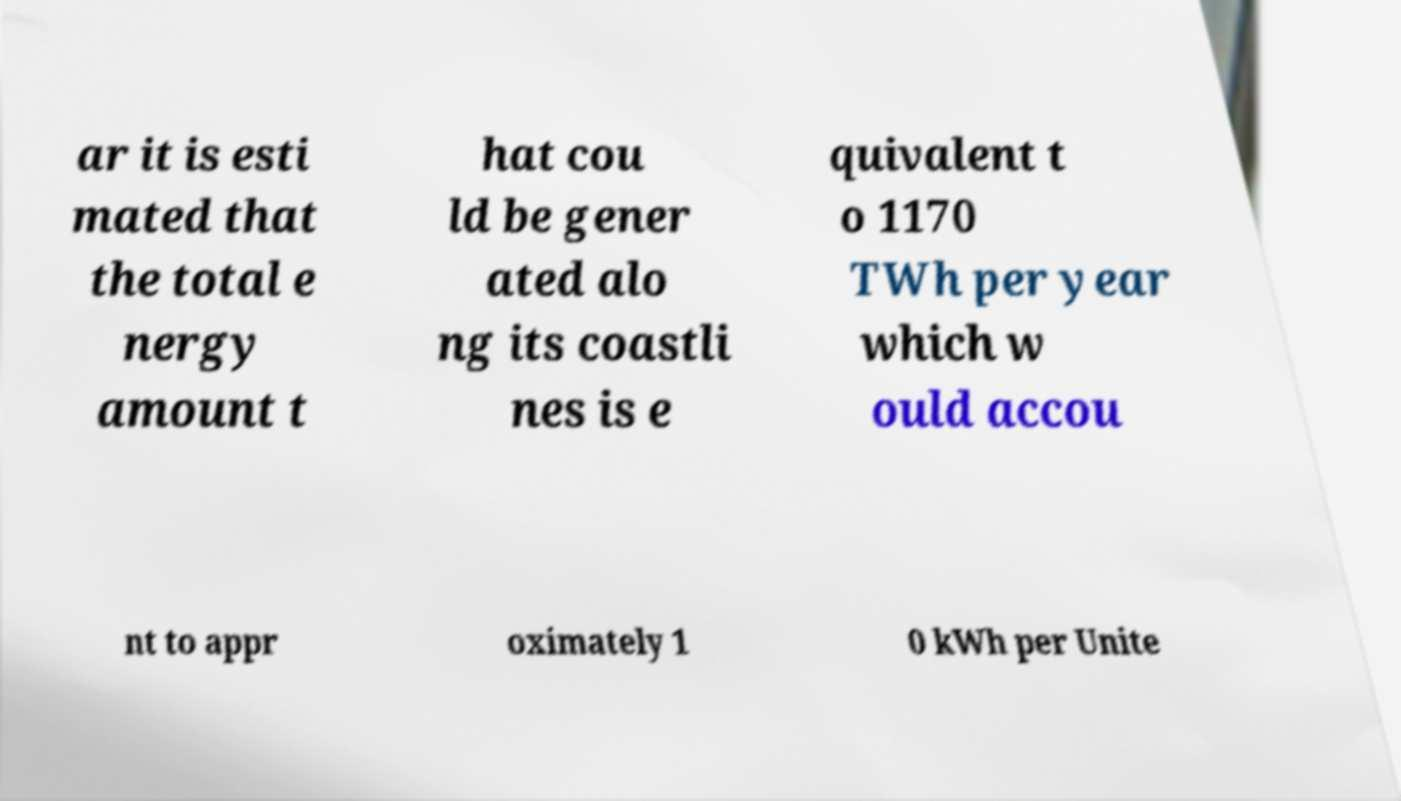I need the written content from this picture converted into text. Can you do that? ar it is esti mated that the total e nergy amount t hat cou ld be gener ated alo ng its coastli nes is e quivalent t o 1170 TWh per year which w ould accou nt to appr oximately 1 0 kWh per Unite 